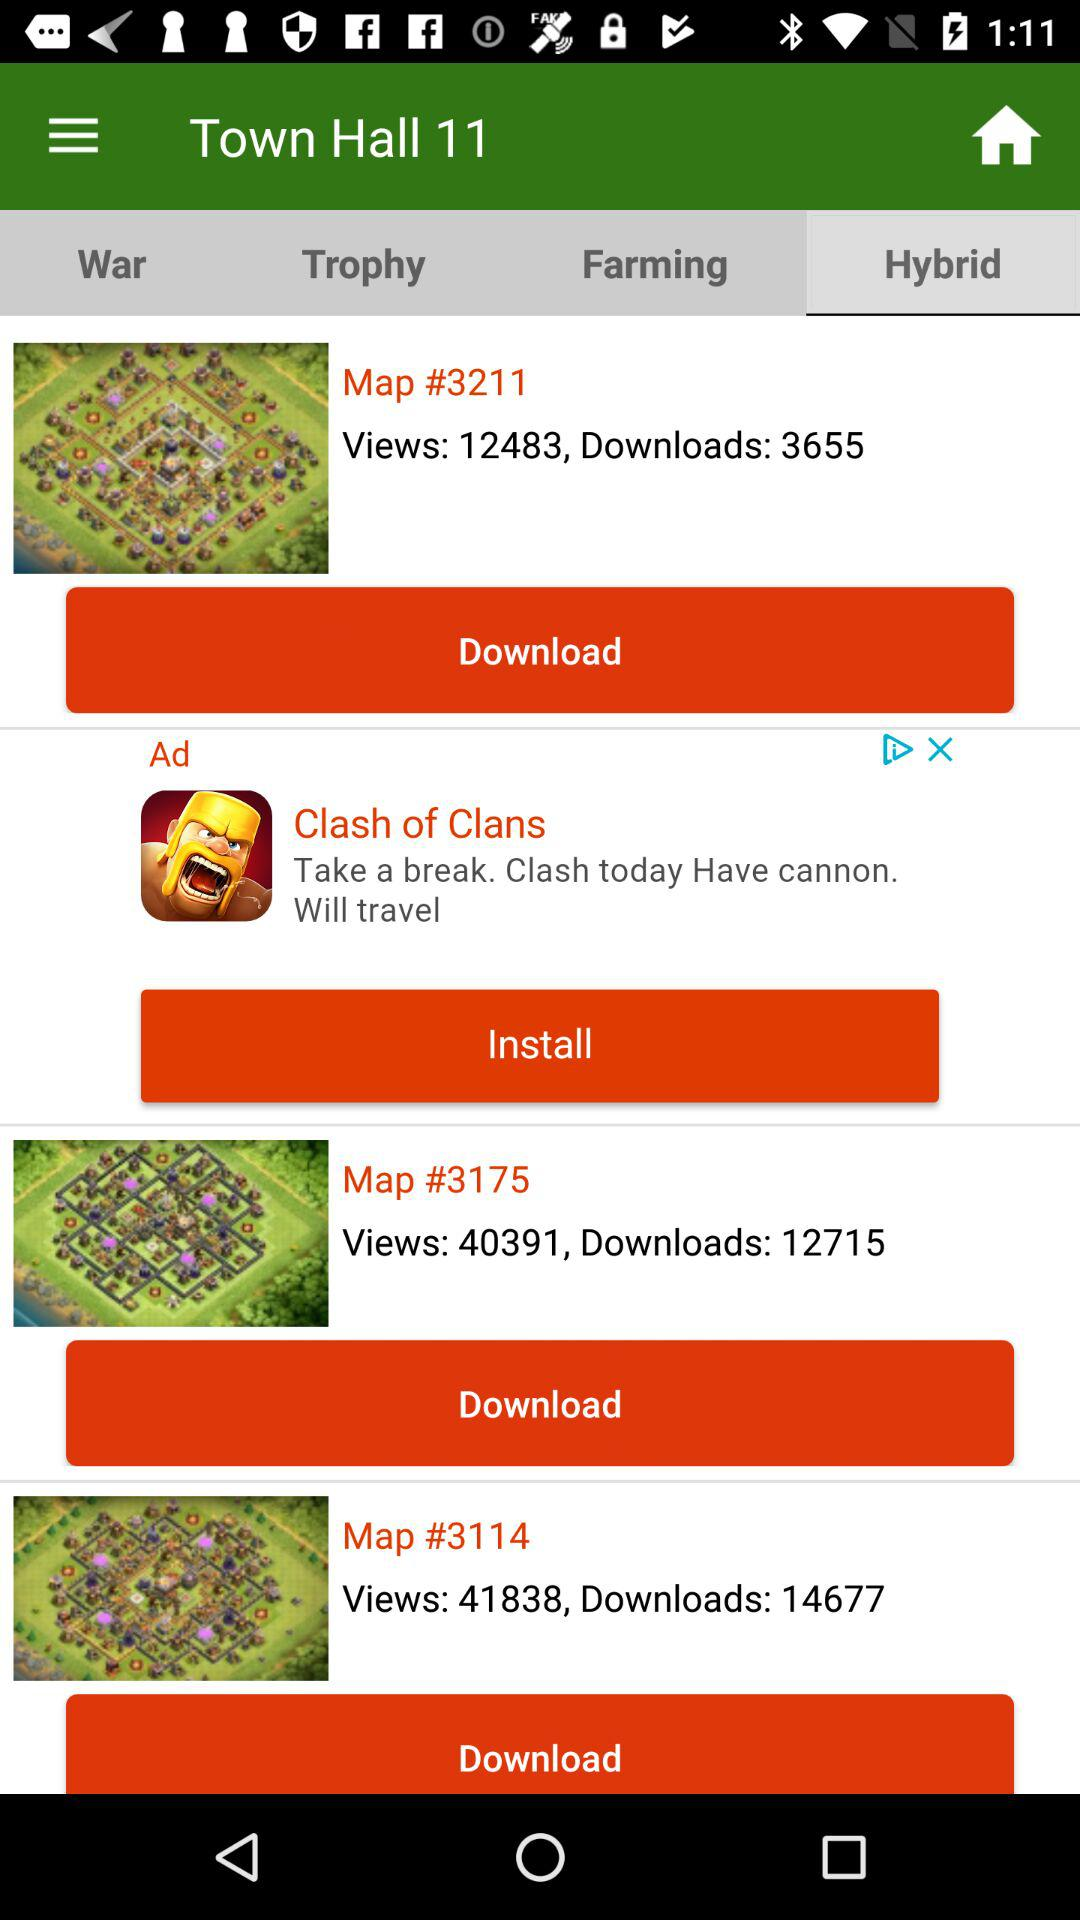How many downloads are on map 3175? There are 12715 downloads on map 3175. 